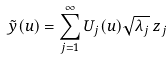Convert formula to latex. <formula><loc_0><loc_0><loc_500><loc_500>\tilde { y } ( u ) = \sum _ { j = 1 } ^ { \infty } U _ { j } ( u ) \sqrt { \lambda _ { j } } \, z _ { j }</formula> 